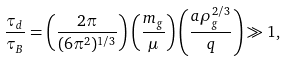Convert formula to latex. <formula><loc_0><loc_0><loc_500><loc_500>\frac { \tau _ { d } } { \tau _ { B } } = \left ( \frac { 2 \pi } { ( 6 \pi ^ { 2 } ) ^ { 1 / 3 } } \right ) \left ( \frac { m _ { g } } { \mu } \right ) \left ( \frac { a \rho _ { g } ^ { 2 / 3 } } { q } \right ) \gg 1 ,</formula> 